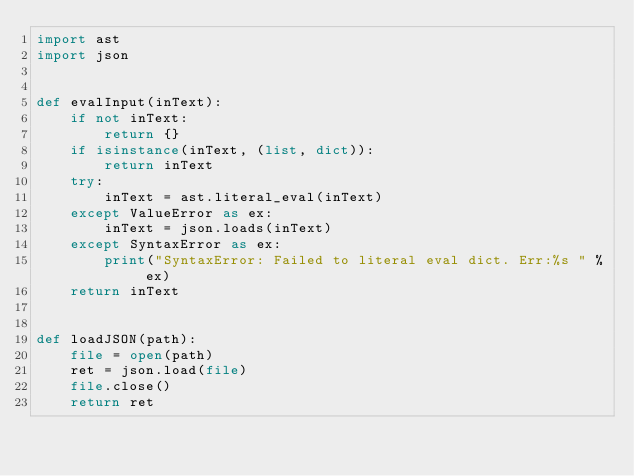<code> <loc_0><loc_0><loc_500><loc_500><_Python_>import ast
import json


def evalInput(inText):
    if not inText:
        return {}
    if isinstance(inText, (list, dict)):
        return inText
    try:
        inText = ast.literal_eval(inText)
    except ValueError as ex:
        inText = json.loads(inText)
    except SyntaxError as ex:
        print("SyntaxError: Failed to literal eval dict. Err:%s " % ex)
    return inText


def loadJSON(path):
    file = open(path)
    ret = json.load(file)
    file.close()
    return ret
</code> 